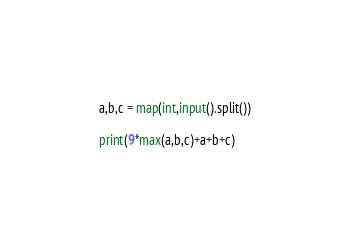Convert code to text. <code><loc_0><loc_0><loc_500><loc_500><_Python_>a,b,c = map(int,input().split())

print(9*max(a,b,c)+a+b+c)
</code> 